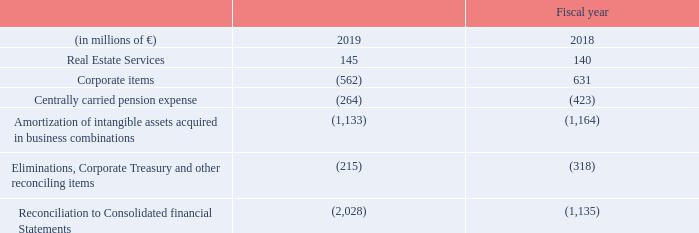A.3.10 Reconciliation to Consolidated Financial Statements
The negative swing in Corporate items was mainly due to large positive effects in fiscal 2018 – the gain of € 900 million resulting from the transfer of Siemens’ shares in Atos SE to Siemens Pension- Trust e. V. and the gain of € 655 million from the sale of OSRAM Licht AG shares. These effects substantially outweighed a positive result in fiscal 2019 from the measurement of a major asset retirement obligation, which was previously reported in Centrally managed portfolio activities. Severance charges within Corporate items were € 99 million (€ 159 million in fiscal 2018).
What caused the negative swing in corporate items? The negative swing in corporate items was mainly due to large positive effects in fiscal 2018 – the gain of € 900 million resulting from the transfer of siemens’ shares in atos se to siemens pension- trust e. v. and the gain of € 655 million from the sale of osram licht ag shares. What were the severance charges within Corporate items?
Answer scale should be: million. 99. What was the Reconciliation to Consolidated financial Statements in 2019?
Answer scale should be: million. (2,028). What was the average Real Estate Services?
Answer scale should be: million. (145 + 140) / 2
Answer: 142.5. What is the increase / (decrease) in Amortization of intangible assets acquired in business combinations from 2018 to 2019?
Answer scale should be: million. 1,133 - 1,164
Answer: -31. What is the increase / (decrease) percentage of Centrally carried pension expense from 2018 to 2019?
Answer scale should be: percent. (264 / 423 - 1)
Answer: -37.59. 